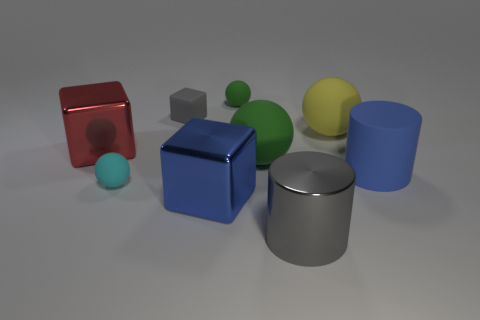There is a cube that is the same color as the rubber cylinder; what is it made of?
Your answer should be compact. Metal. What material is the gray object that is in front of the big red metal thing?
Ensure brevity in your answer.  Metal. Are the yellow thing that is behind the gray shiny cylinder and the tiny cyan object made of the same material?
Offer a terse response. Yes. How many objects are either small green metal spheres or large objects that are in front of the yellow rubber object?
Your answer should be very brief. 5. The yellow matte object that is the same shape as the small cyan object is what size?
Provide a succinct answer. Large. Are there any gray objects in front of the gray block?
Give a very brief answer. Yes. There is a large matte ball in front of the large yellow object; is it the same color as the metal block left of the blue block?
Your answer should be very brief. No. Is there another shiny thing that has the same shape as the red metallic object?
Your answer should be compact. Yes. How many other things are there of the same color as the small block?
Offer a very short reply. 1. The tiny object that is in front of the blue thing that is right of the green matte ball that is behind the big green sphere is what color?
Offer a terse response. Cyan. 